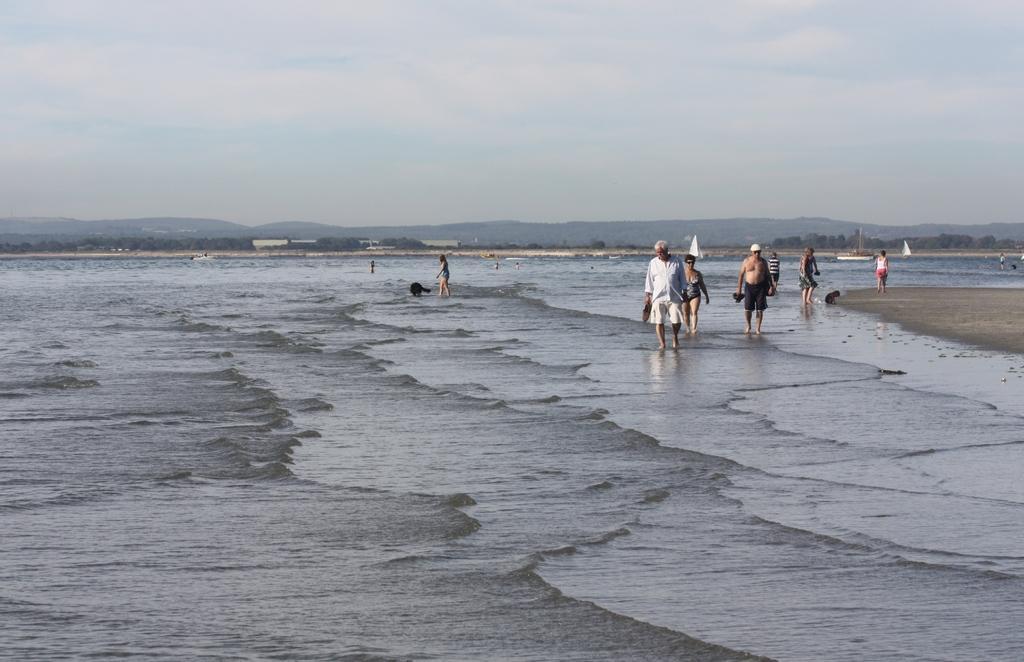Could you give a brief overview of what you see in this image? As we can see in the image there is water, few people here and there and in the background there are trees. At the top there is sky. 